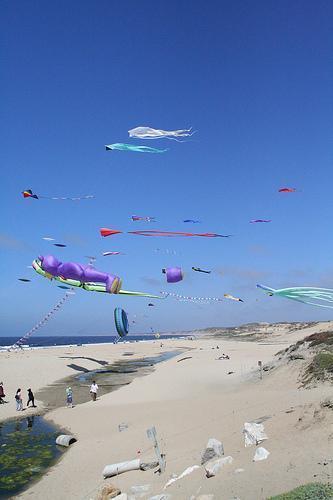How many white kites are shown?
Give a very brief answer. 1. 